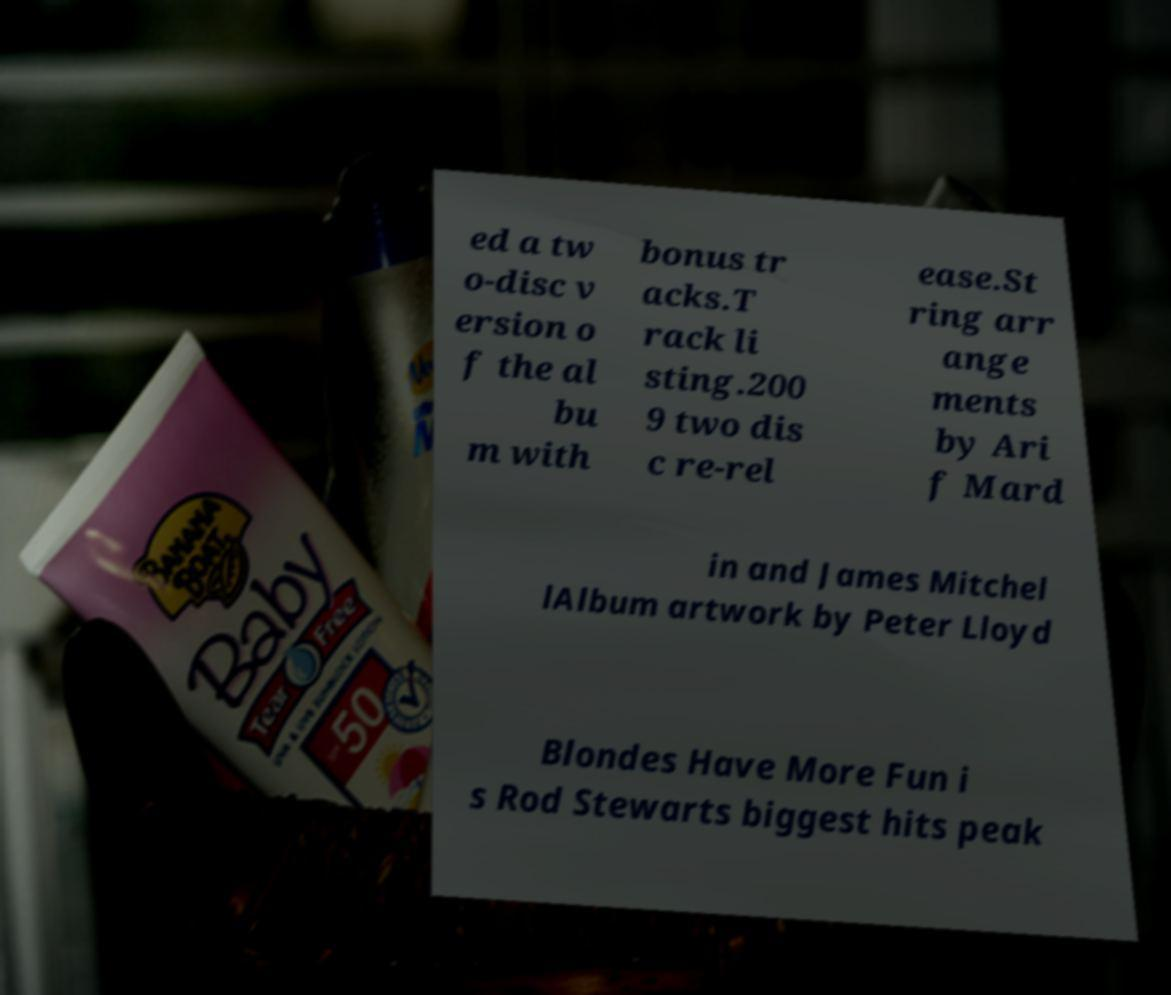I need the written content from this picture converted into text. Can you do that? ed a tw o-disc v ersion o f the al bu m with bonus tr acks.T rack li sting.200 9 two dis c re-rel ease.St ring arr ange ments by Ari f Mard in and James Mitchel lAlbum artwork by Peter Lloyd Blondes Have More Fun i s Rod Stewarts biggest hits peak 